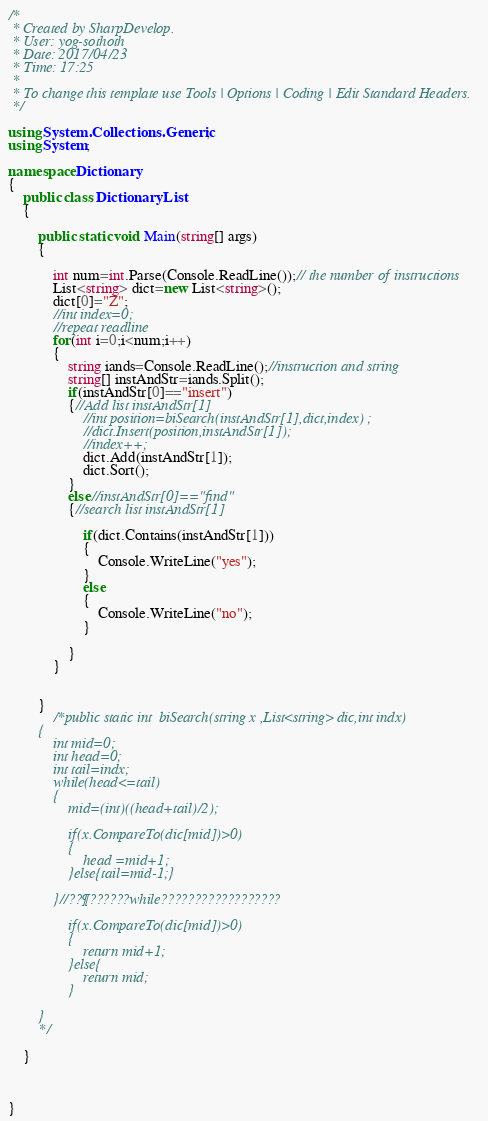<code> <loc_0><loc_0><loc_500><loc_500><_C#_>/*
 * Created by SharpDevelop.
 * User: yog-sothoth
 * Date: 2017/04/23
 * Time: 17:25
 * 
 * To change this template use Tools | Options | Coding | Edit Standard Headers.
 */

using System.Collections.Generic;
using System;

namespace Dictionary
{	
	public class DictionaryList
	{
		
		public static void Main(string[] args)
		{
			
			int num=int.Parse(Console.ReadLine());// the number of instructions
			List<string> dict=new List<string>();
			dict[0]="Z";
			//int index=0;
			//repeat readline
			for(int i=0;i<num;i++)
			{
				string iands=Console.ReadLine();//instruction and string
				string[] instAndStr=iands.Split();
				if(instAndStr[0]=="insert")
				{//Add list instAndStr[1]
					//int position=biSearch(instAndStr[1],dict,index) ;
					//dict.Insert(position,instAndStr[1]);
					//index++;
					dict.Add(instAndStr[1]);
					dict.Sort();
				}
				else//instAndStr[0]=="find"
				{//search list instAndStr[1]
					
					if(dict.Contains(instAndStr[1]))
					{
						Console.WriteLine("yes");
					}
					else
					{
						Console.WriteLine("no");
					}
					
				}
			}
			
			
		}
			/*public static int  biSearch(string x ,List<string> dic,int indx)
		{
			int mid=0;
			int head=0;
			int tail=indx;
			while(head<=tail)
			{
				mid=(int)((head+tail)/2);
					
				if(x.CompareTo(dic[mid])>0)
				{
					head =mid+1;
				}else{tail=mid-1;}
			
			}//??¶??????while??????????????????
			
				if(x.CompareTo(dic[mid])>0)
				{
					return mid+1;
				}else{
					return mid;
				}
				
		}
		*/
		
	}
	


}</code> 